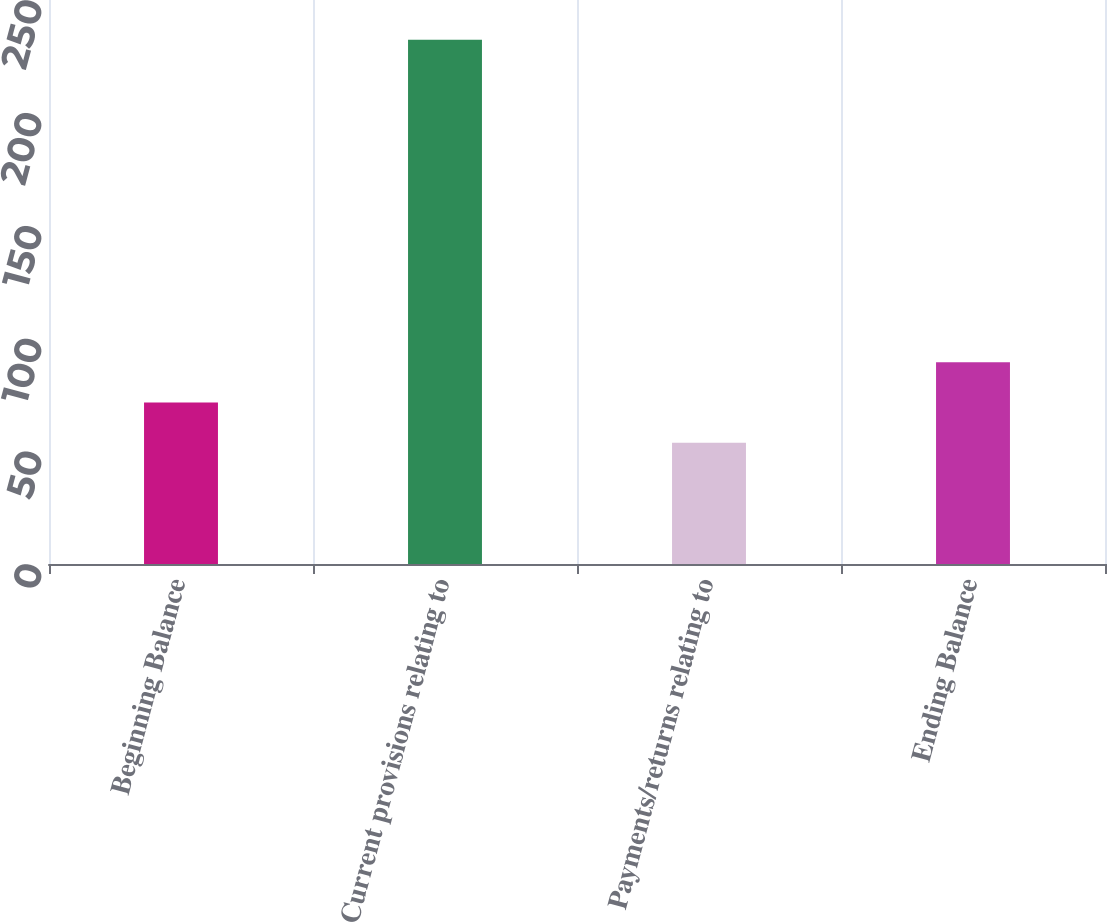Convert chart. <chart><loc_0><loc_0><loc_500><loc_500><bar_chart><fcel>Beginning Balance<fcel>Current provisions relating to<fcel>Payments/returns relating to<fcel>Ending Balance<nl><fcel>71.57<fcel>232.4<fcel>53.7<fcel>89.44<nl></chart> 